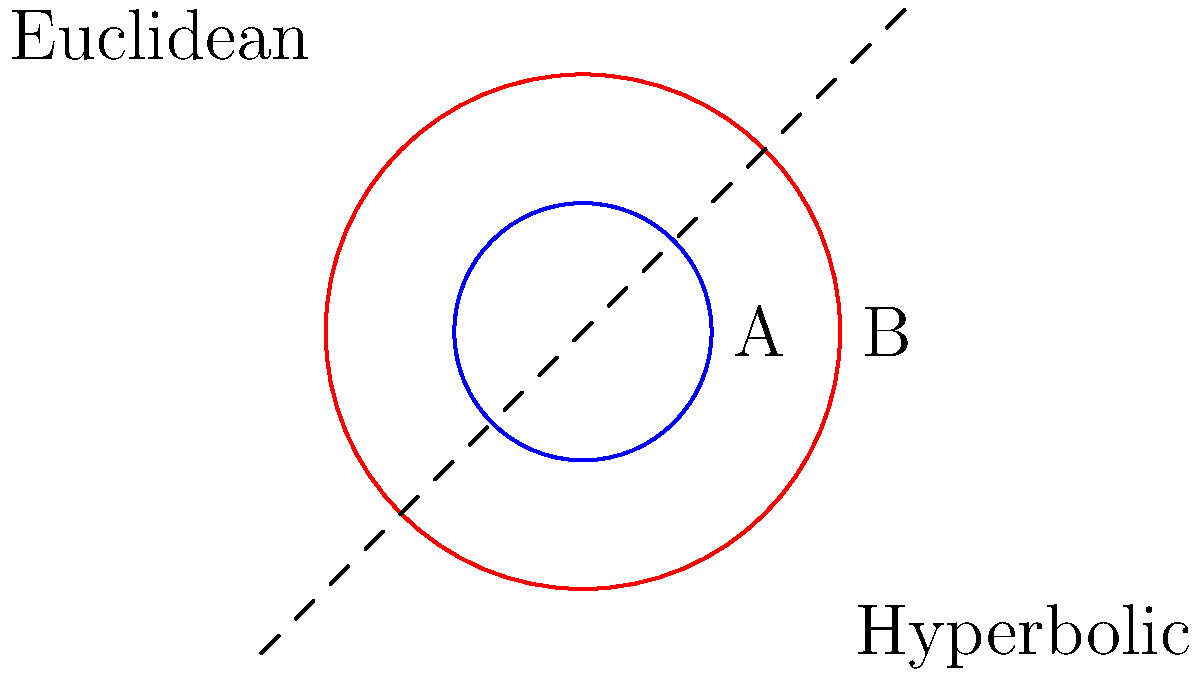Look at the picture. There are two circles, a blue one (A) and a red one (B). In normal (Euclidean) geometry, the red circle is 4 times bigger than the blue one. But in a special kind of geometry called hyperbolic geometry, it's different. In hyperbolic geometry, how many times bigger is the red circle compared to the blue one?

a) 2 times
b) 3 times
c) 4 times
d) More than 4 times Let's think about this step by step:

1. In Euclidean geometry:
   - The area of a circle is given by the formula $A = \pi r^2$
   - The blue circle (A) has a radius of 1, so its area is $A_A = \pi (1)^2 = \pi$
   - The red circle (B) has a radius of 2, so its area is $A_B = \pi (2)^2 = 4\pi$
   - The red circle is 4 times bigger than the blue one in Euclidean geometry

2. In hyperbolic geometry:
   - The area of a circle is given by the formula $A = 4\pi \sinh^2(\frac{r}{2})$
   - For the blue circle (A): $A_A = 4\pi \sinh^2(\frac{1}{2})$
   - For the red circle (B): $A_B = 4\pi \sinh^2(\frac{2}{2}) = 4\pi \sinh^2(1)$

3. To compare the areas in hyperbolic geometry:
   $\frac{A_B}{A_A} = \frac{4\pi \sinh^2(1)}{4\pi \sinh^2(\frac{1}{2})} = \frac{\sinh^2(1)}{\sinh^2(\frac{1}{2})}$

4. Calculate this ratio:
   $\frac{\sinh^2(1)}{\sinh^2(\frac{1}{2})} \approx 5.43$

5. This means in hyperbolic geometry, the red circle is about 5.43 times bigger than the blue one, which is more than 4 times.
Answer: d) More than 4 times 